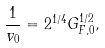<formula> <loc_0><loc_0><loc_500><loc_500>\frac { 1 } { v _ { 0 } } = 2 ^ { 1 / 4 } G _ { F , 0 } ^ { 1 / 2 } ,</formula> 